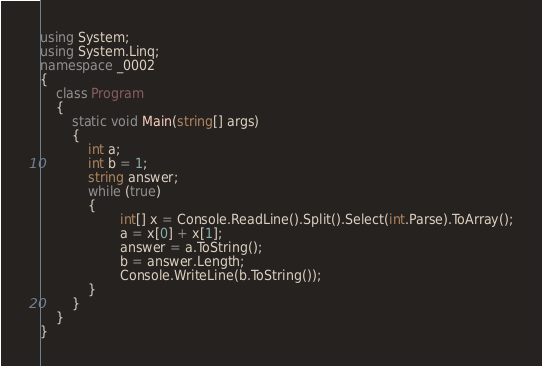Convert code to text. <code><loc_0><loc_0><loc_500><loc_500><_C#_>using System;
using System.Linq;
namespace _0002
{
    class Program
    {
        static void Main(string[] args)
        {
            int a;
            int b = 1;
            string answer;
            while (true)
            {
                    int[] x = Console.ReadLine().Split().Select(int.Parse).ToArray();
                    a = x[0] + x[1];
                    answer = a.ToString();
                    b = answer.Length;
                    Console.WriteLine(b.ToString());
            }
        }
    }
}</code> 